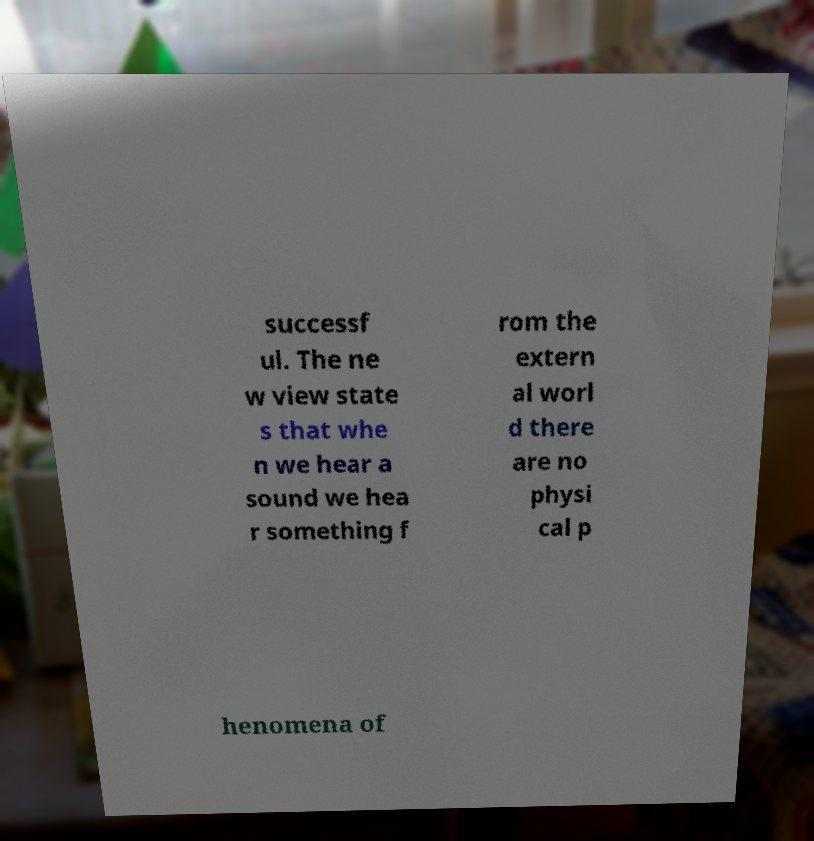Please read and relay the text visible in this image. What does it say? successf ul. The ne w view state s that whe n we hear a sound we hea r something f rom the extern al worl d there are no physi cal p henomena of 